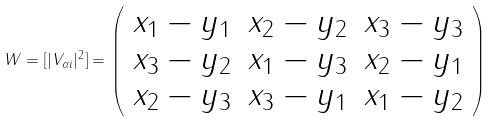<formula> <loc_0><loc_0><loc_500><loc_500>W = [ | V _ { \alpha i } | ^ { 2 } ] = \left ( \begin{array} { c c c } x _ { 1 } - y _ { 1 } & x _ { 2 } - y _ { 2 } & x _ { 3 } - y _ { 3 } \\ x _ { 3 } - y _ { 2 } & x _ { 1 } - y _ { 3 } & x _ { 2 } - y _ { 1 } \\ x _ { 2 } - y _ { 3 } & x _ { 3 } - y _ { 1 } & x _ { 1 } - y _ { 2 } \\ \end{array} \right )</formula> 